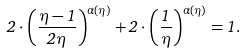Convert formula to latex. <formula><loc_0><loc_0><loc_500><loc_500>2 \cdot { \left ( \frac { \eta - 1 } { 2 \eta } \right ) } ^ { \alpha ( \eta ) } + 2 \cdot { \left ( \frac { 1 } { \eta } \right ) } ^ { \alpha ( \eta ) } = 1 .</formula> 